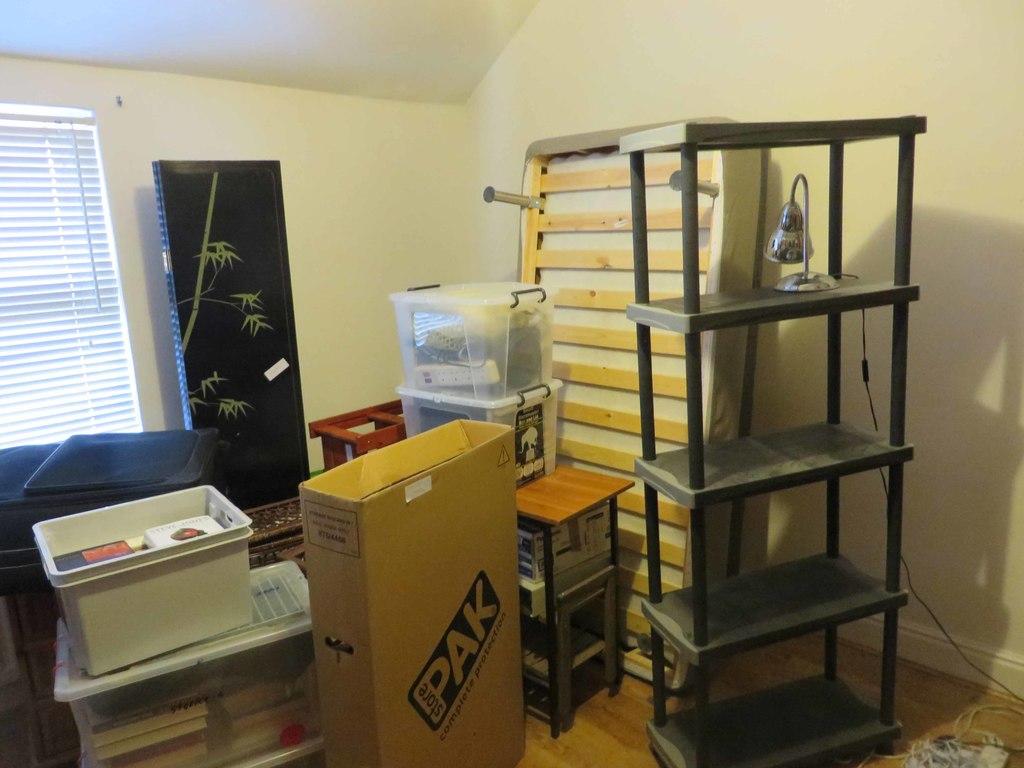What company name is printed on the box in the middle of the room?
Make the answer very short. Store pak. 